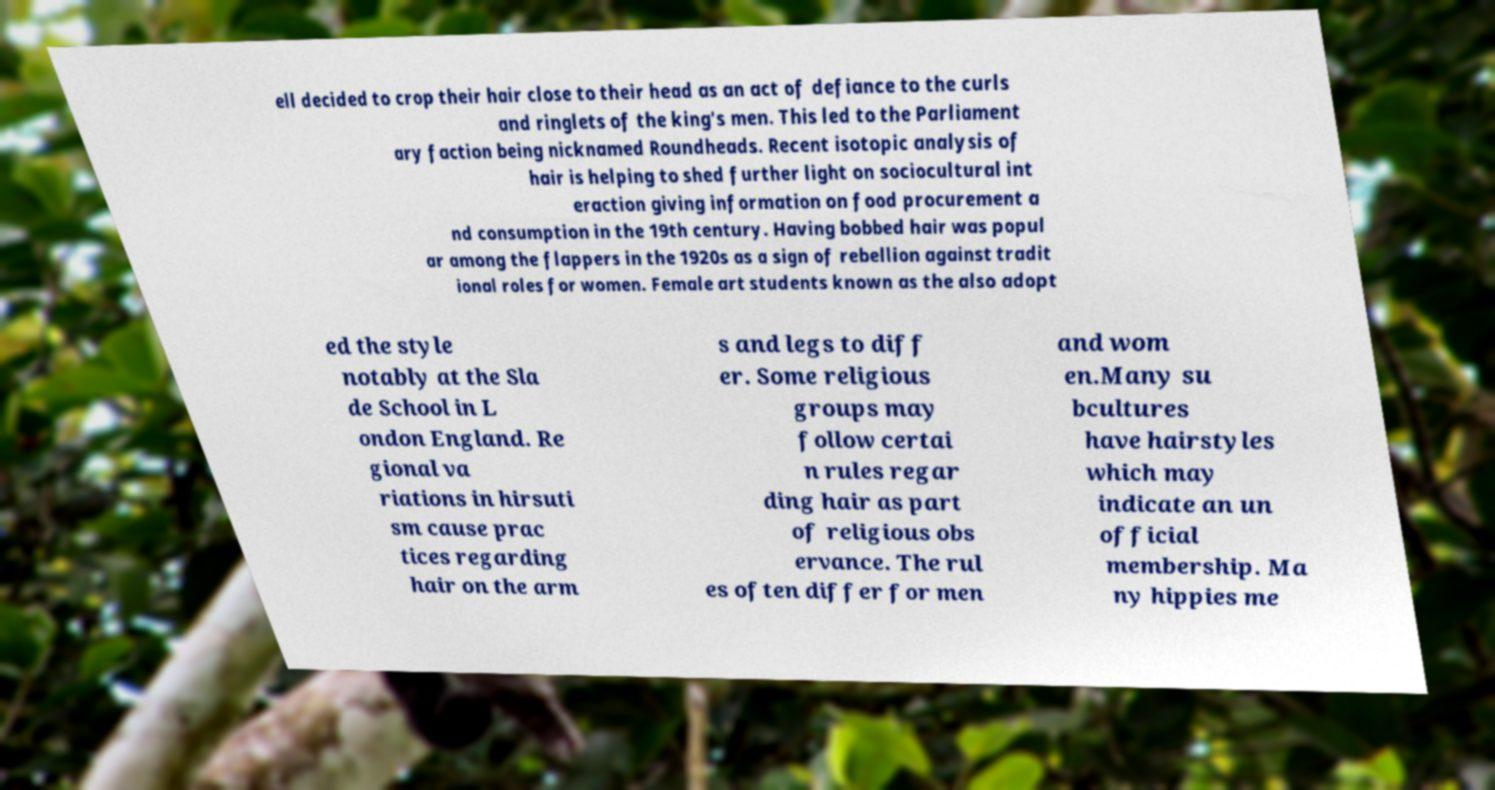Can you read and provide the text displayed in the image?This photo seems to have some interesting text. Can you extract and type it out for me? ell decided to crop their hair close to their head as an act of defiance to the curls and ringlets of the king's men. This led to the Parliament ary faction being nicknamed Roundheads. Recent isotopic analysis of hair is helping to shed further light on sociocultural int eraction giving information on food procurement a nd consumption in the 19th century. Having bobbed hair was popul ar among the flappers in the 1920s as a sign of rebellion against tradit ional roles for women. Female art students known as the also adopt ed the style notably at the Sla de School in L ondon England. Re gional va riations in hirsuti sm cause prac tices regarding hair on the arm s and legs to diff er. Some religious groups may follow certai n rules regar ding hair as part of religious obs ervance. The rul es often differ for men and wom en.Many su bcultures have hairstyles which may indicate an un official membership. Ma ny hippies me 